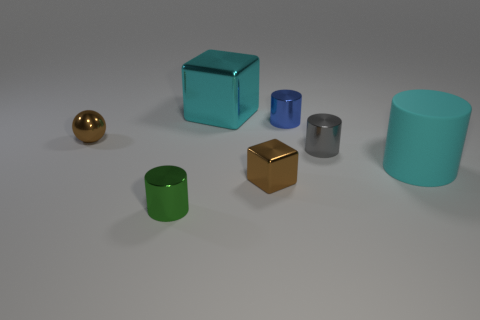Subtract all yellow cylinders. Subtract all yellow blocks. How many cylinders are left? 4 Add 1 large rubber cylinders. How many objects exist? 8 Subtract all spheres. How many objects are left? 6 Add 2 shiny cylinders. How many shiny cylinders are left? 5 Add 5 tiny cylinders. How many tiny cylinders exist? 8 Subtract 0 yellow cylinders. How many objects are left? 7 Subtract all gray objects. Subtract all small gray shiny things. How many objects are left? 5 